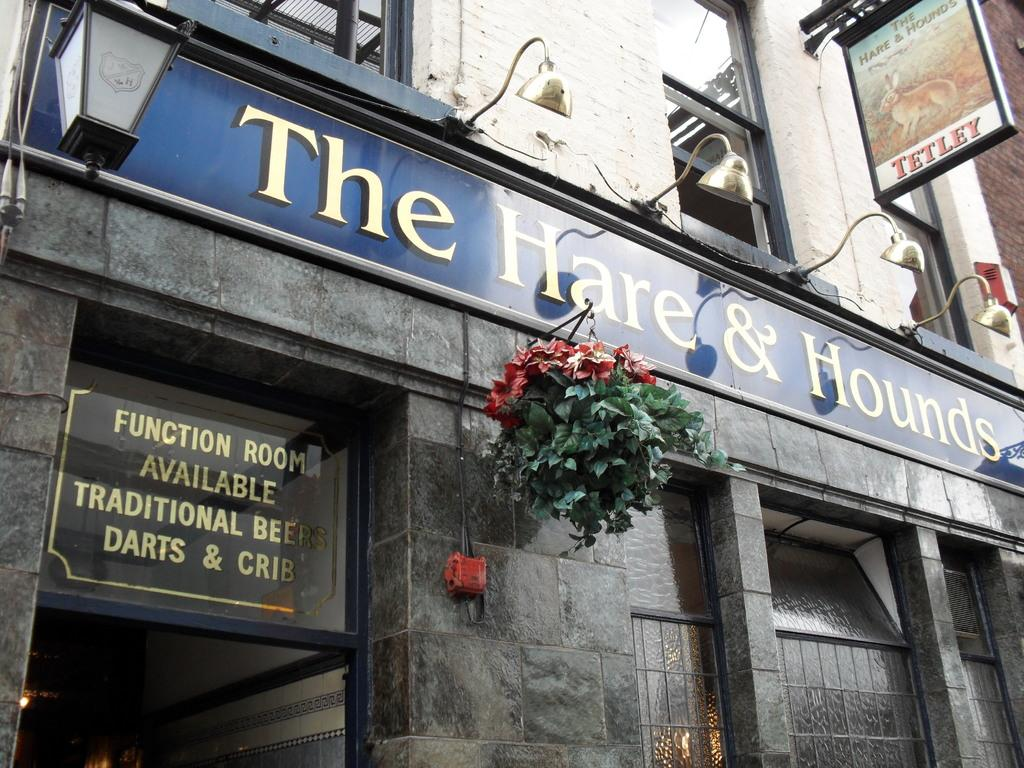<image>
Create a compact narrative representing the image presented. The Hare and Hounds restaurant sitting outside with flowers 